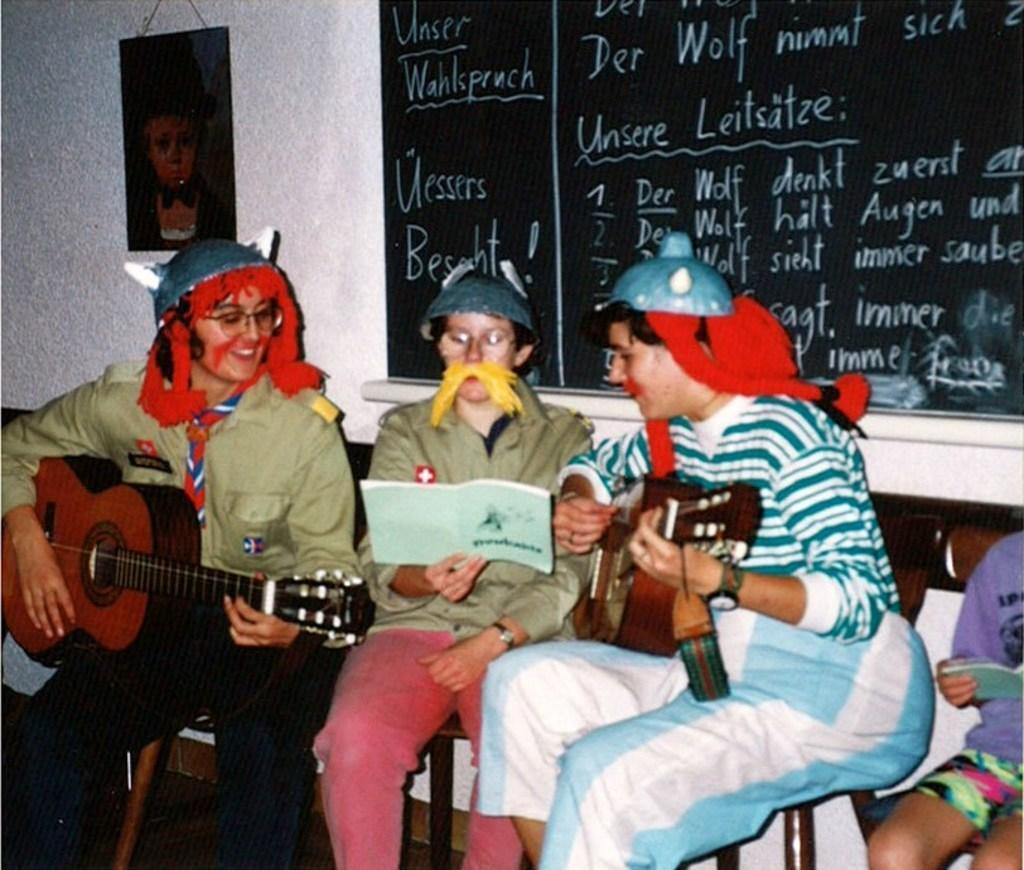How would you summarize this image in a sentence or two? In this picture we can see three persons on left side person holding guitar in his hand middle is holding book and on right side person also holding guitar and they are sitting on chair and in background we can see some poster, board and here person is sitting. 